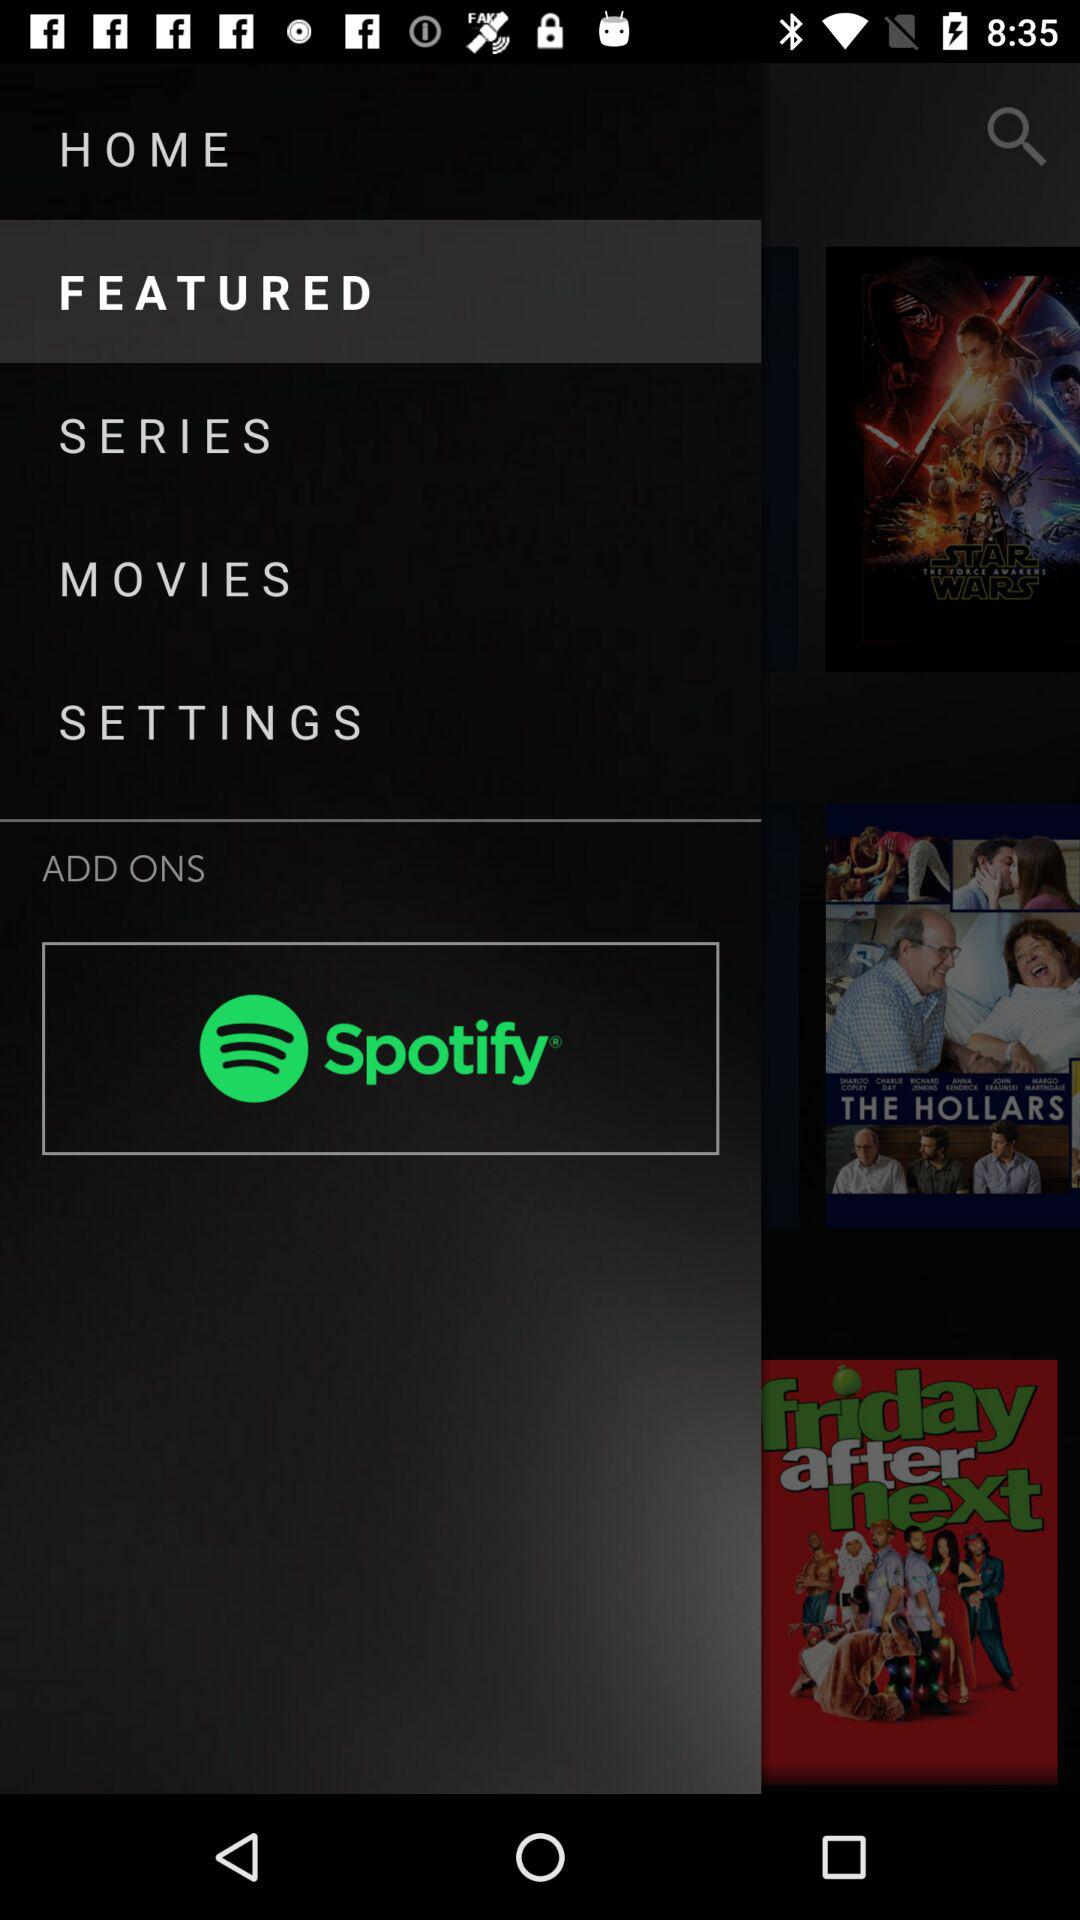What is the app name? The app name is "Spotify". 